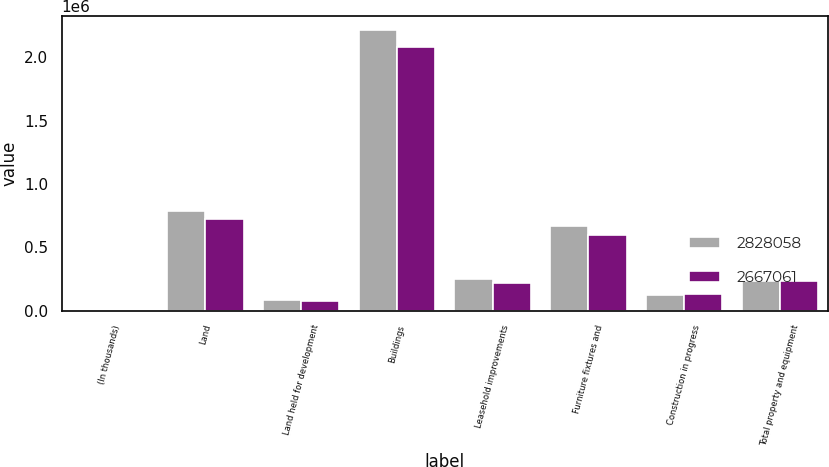Convert chart. <chart><loc_0><loc_0><loc_500><loc_500><stacked_bar_chart><ecel><fcel>(In thousands)<fcel>Land<fcel>Land held for development<fcel>Buildings<fcel>Leasehold improvements<fcel>Furniture fixtures and<fcel>Construction in progress<fcel>Total property and equipment<nl><fcel>2.82806e+06<fcel>2019<fcel>789125<fcel>81100<fcel>2.21193e+06<fcel>247121<fcel>671166<fcel>125010<fcel>231118<nl><fcel>2.66706e+06<fcel>2018<fcel>722173<fcel>77145<fcel>2.08178e+06<fcel>215114<fcel>600739<fcel>134354<fcel>231118<nl></chart> 